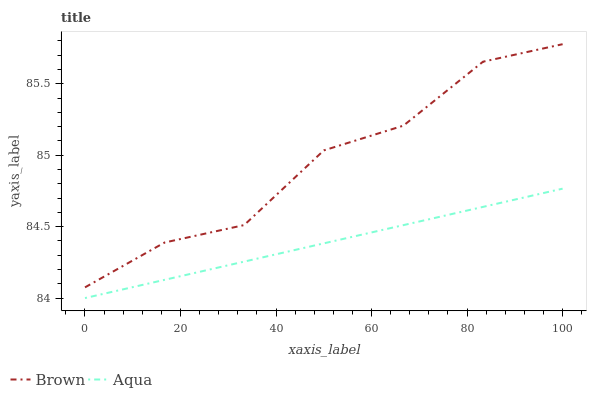Does Aqua have the minimum area under the curve?
Answer yes or no. Yes. Does Brown have the maximum area under the curve?
Answer yes or no. Yes. Does Aqua have the maximum area under the curve?
Answer yes or no. No. Is Aqua the smoothest?
Answer yes or no. Yes. Is Brown the roughest?
Answer yes or no. Yes. Is Aqua the roughest?
Answer yes or no. No. Does Aqua have the highest value?
Answer yes or no. No. Is Aqua less than Brown?
Answer yes or no. Yes. Is Brown greater than Aqua?
Answer yes or no. Yes. Does Aqua intersect Brown?
Answer yes or no. No. 